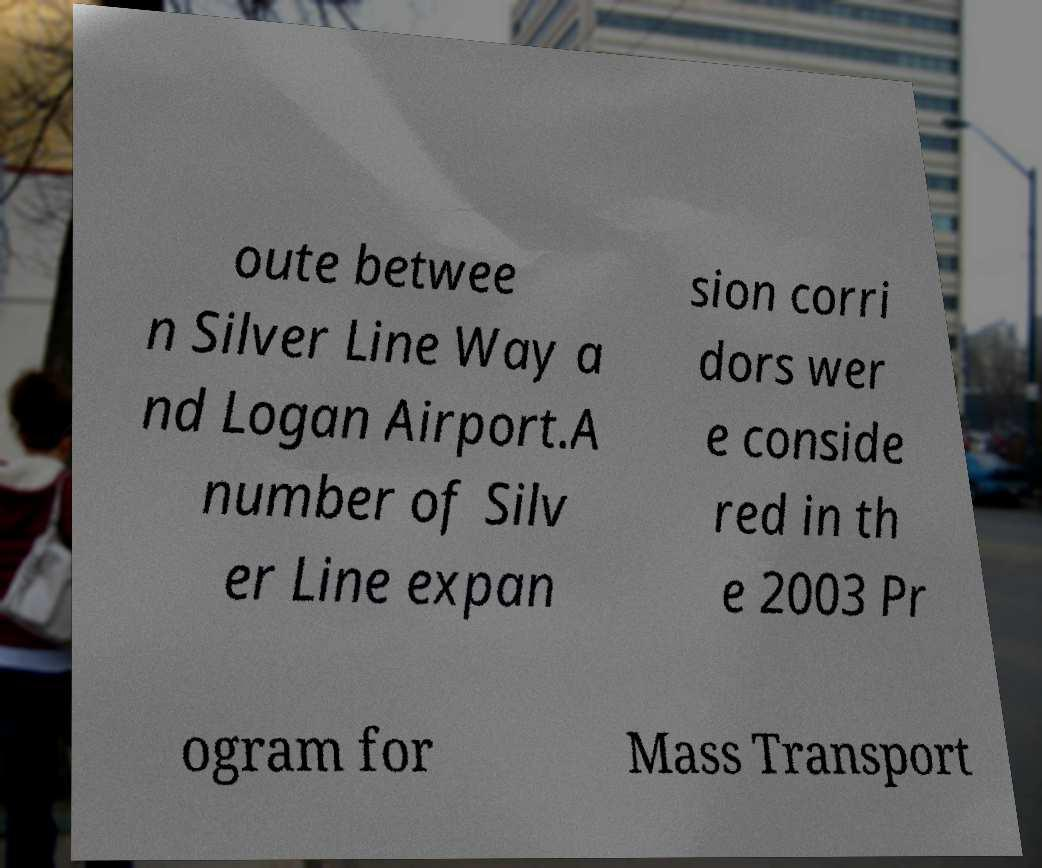I need the written content from this picture converted into text. Can you do that? oute betwee n Silver Line Way a nd Logan Airport.A number of Silv er Line expan sion corri dors wer e conside red in th e 2003 Pr ogram for Mass Transport 